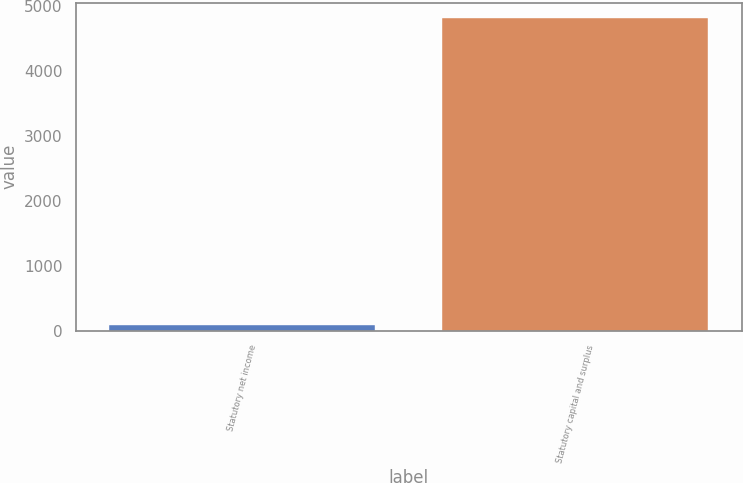Convert chart. <chart><loc_0><loc_0><loc_500><loc_500><bar_chart><fcel>Statutory net income<fcel>Statutory capital and surplus<nl><fcel>83.3<fcel>4810.2<nl></chart> 